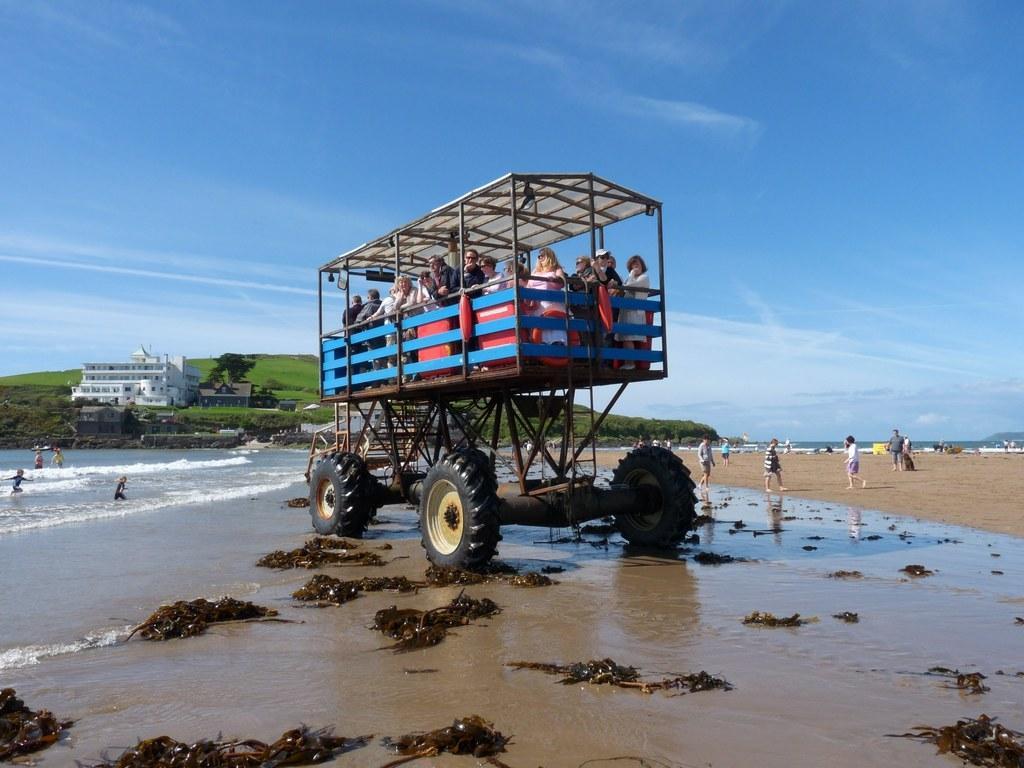Describe this image in one or two sentences. In this image, we can see a vehicle, a group of people are standing here. On the left side, we can see the sea. Here we can see few people. building, trees, mountain. Background there is a sky. 